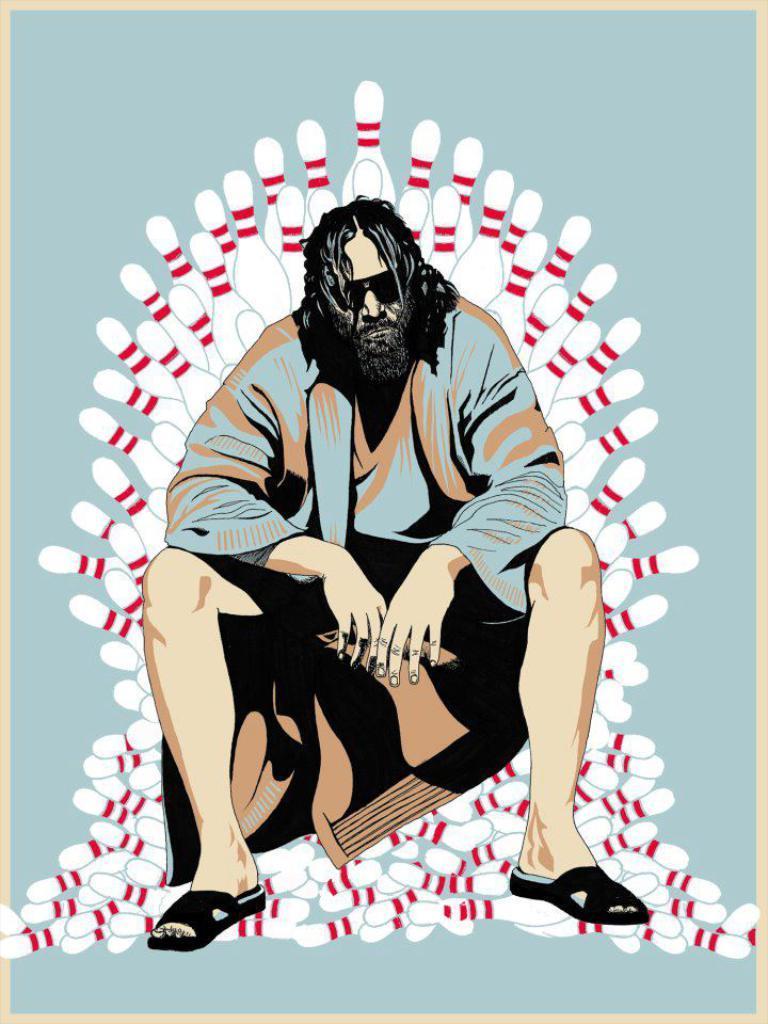Please provide a concise description of this image. This is an animated image I can see a person sitting and behind him I can see bowling pins. 